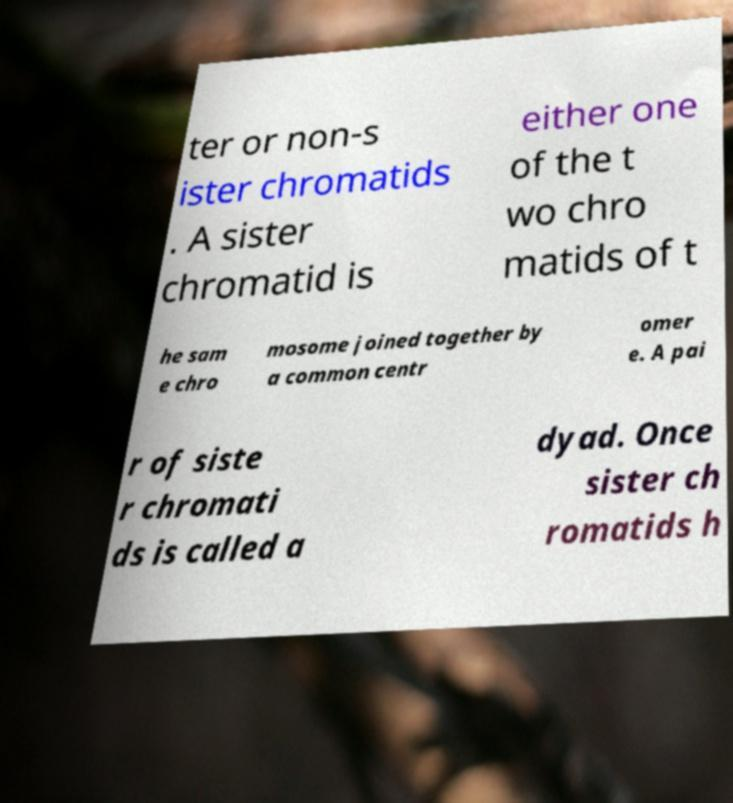Could you extract and type out the text from this image? ter or non-s ister chromatids . A sister chromatid is either one of the t wo chro matids of t he sam e chro mosome joined together by a common centr omer e. A pai r of siste r chromati ds is called a dyad. Once sister ch romatids h 